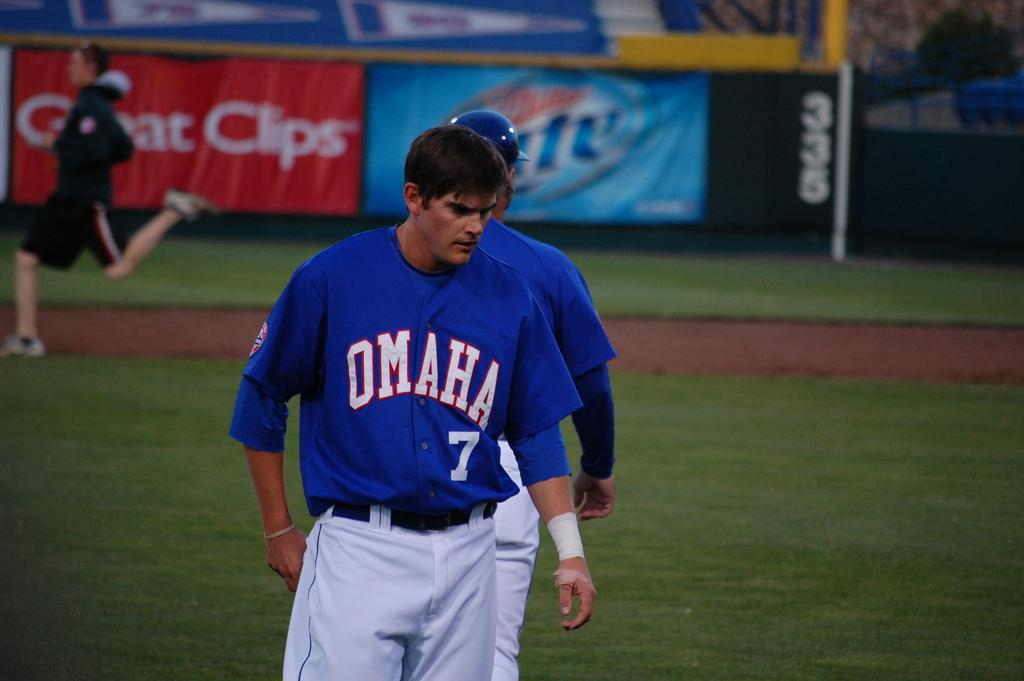<image>
Offer a succinct explanation of the picture presented. A baseball player from Omaha is walking on a field. 